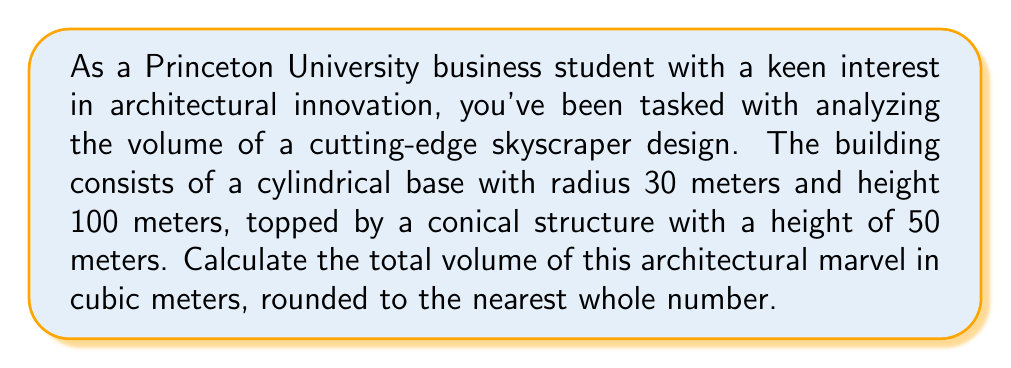Can you answer this question? Let's break this down step-by-step:

1. Calculate the volume of the cylindrical base:
   The formula for the volume of a cylinder is $V_{cylinder} = \pi r^2 h$
   $$V_{cylinder} = \pi \cdot 30^2 \cdot 100 = 282,743.34 \text{ m}^3$$

2. Calculate the volume of the conical top:
   The formula for the volume of a cone is $V_{cone} = \frac{1}{3}\pi r^2 h$
   $$V_{cone} = \frac{1}{3} \cdot \pi \cdot 30^2 \cdot 50 = 47,123.89 \text{ m}^3$$

3. Sum the volumes to get the total:
   $$V_{total} = V_{cylinder} + V_{cone} = 282,743.34 + 47,123.89 = 329,867.23 \text{ m}^3$$

4. Round to the nearest whole number:
   $$V_{total} \approx 329,867 \text{ m}^3$$
Answer: 329,867 m³ 